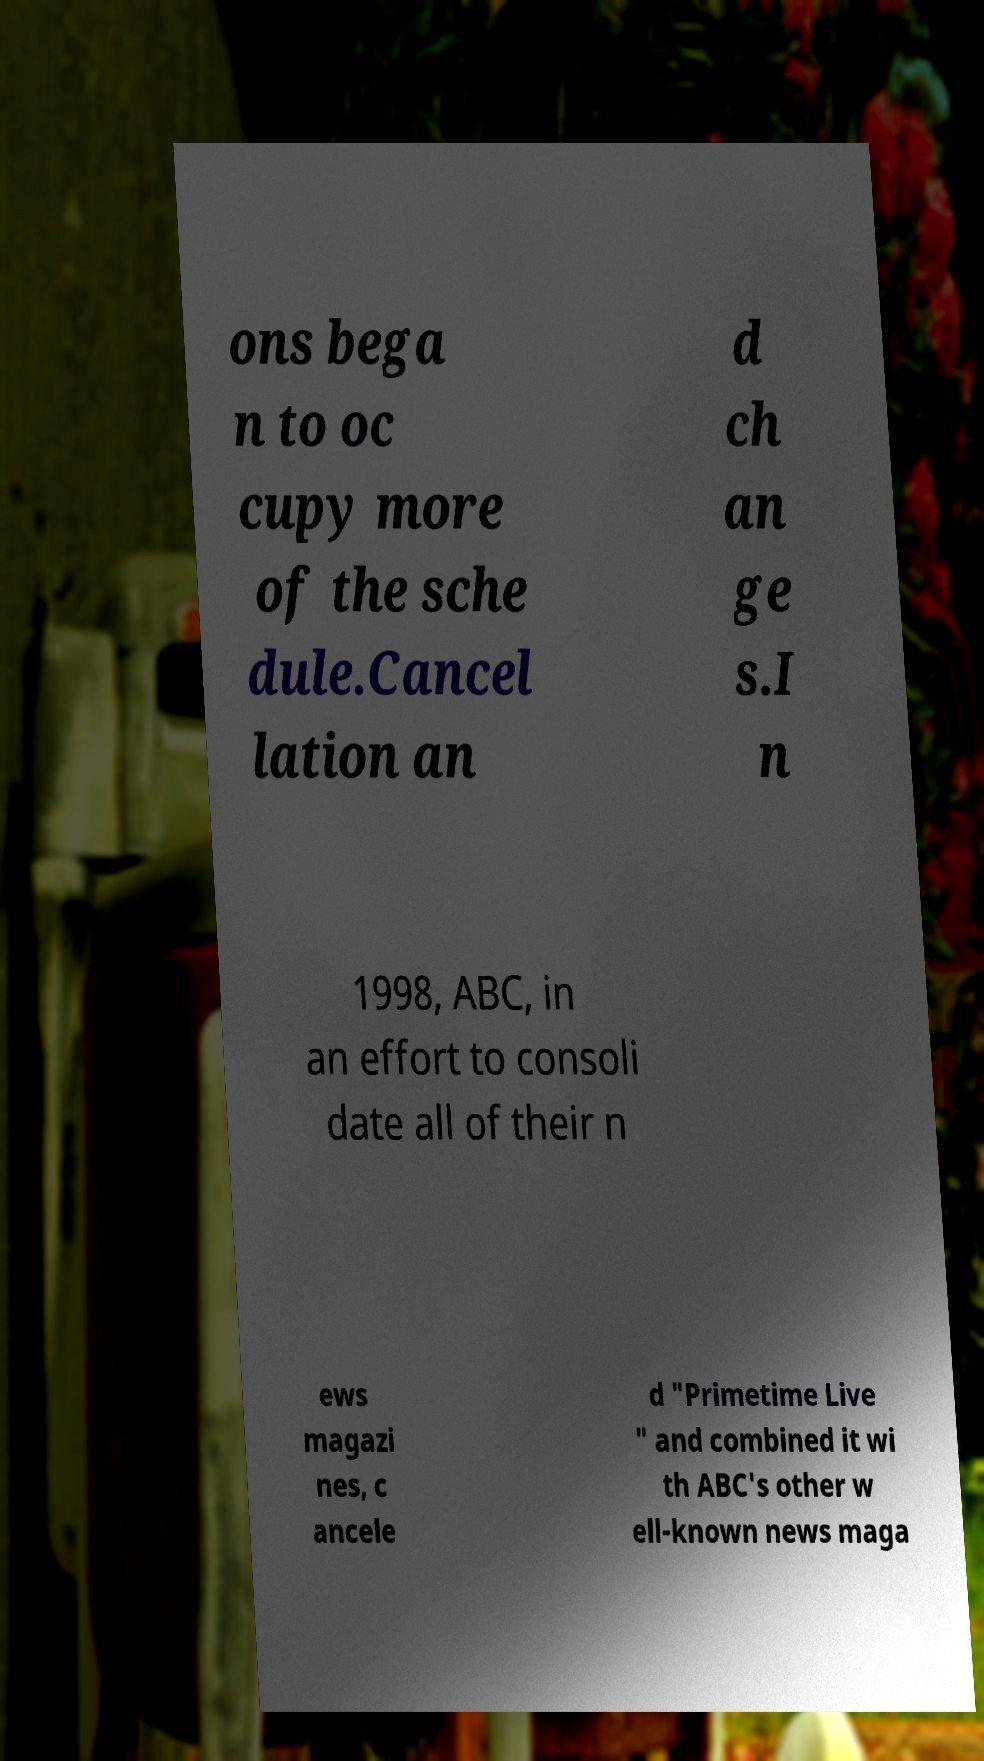Could you extract and type out the text from this image? ons bega n to oc cupy more of the sche dule.Cancel lation an d ch an ge s.I n 1998, ABC, in an effort to consoli date all of their n ews magazi nes, c ancele d "Primetime Live " and combined it wi th ABC's other w ell-known news maga 